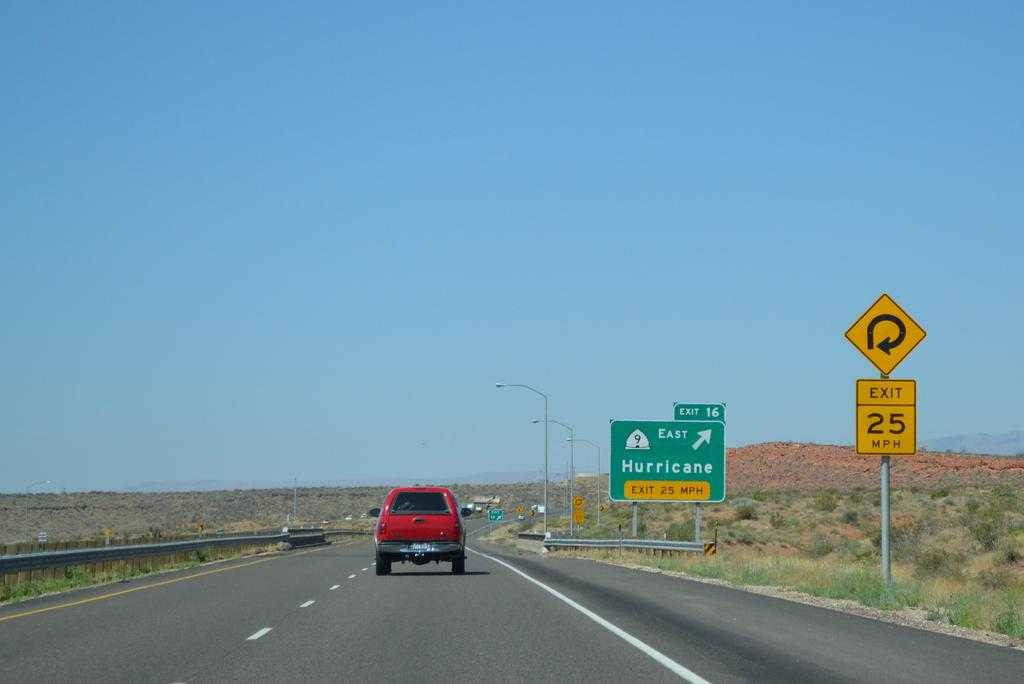<image>
Write a terse but informative summary of the picture. a rural highway with an exit sign for 25 MPH 